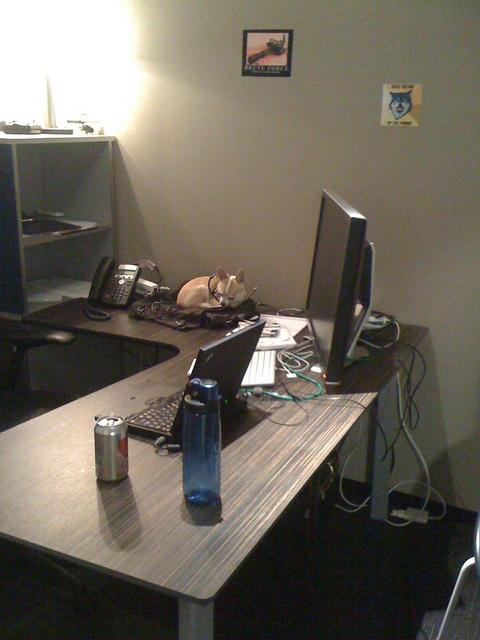What is the dog sleeping?
Give a very brief answer. Desk. How many laptops are there?
Concise answer only. 1. How many computers are shown?
Concise answer only. 2. What room is this?
Answer briefly. Office. Is the light on?
Short answer required. Yes. Where is this?
Keep it brief. Office. 